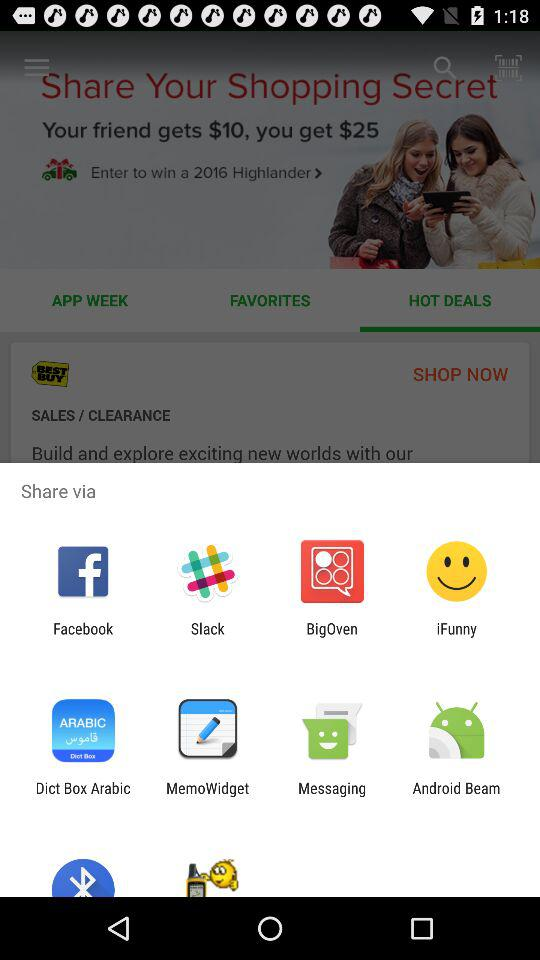Through which application can we share? You can share through "Facebook", "Slack", "BigOven", "iFunny", "Dict Box Arabic", "MemoWidget", "Messaging" and "Android Beam". 